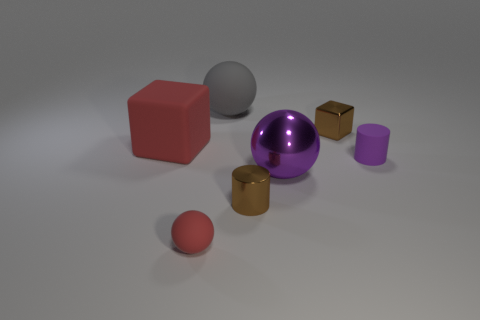Add 1 big red rubber objects. How many objects exist? 8 Subtract all spheres. How many objects are left? 4 Subtract all gray objects. Subtract all brown cubes. How many objects are left? 5 Add 6 big purple balls. How many big purple balls are left? 7 Add 5 metal blocks. How many metal blocks exist? 6 Subtract 1 red cubes. How many objects are left? 6 